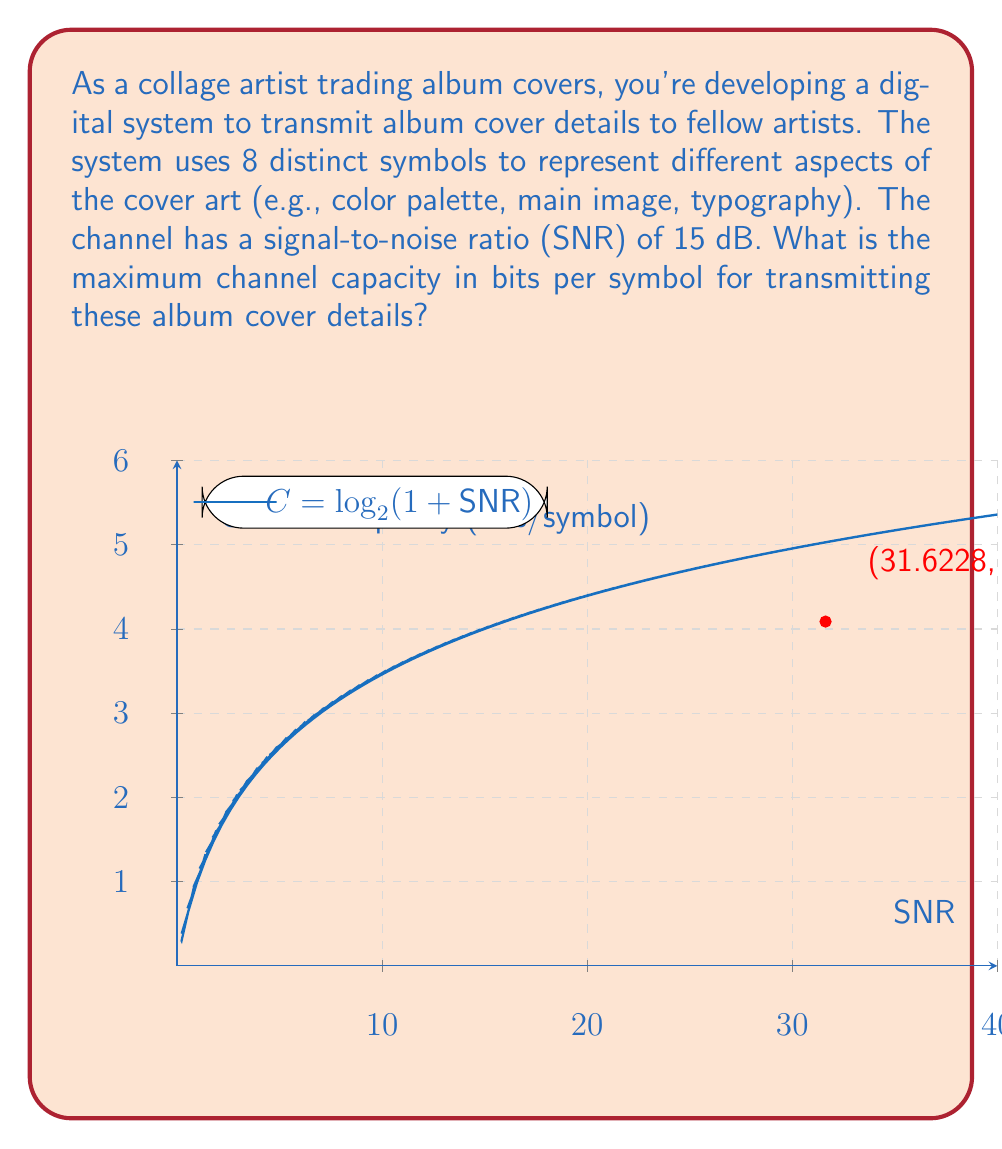Can you solve this math problem? To solve this problem, we'll use the Shannon-Hartley theorem, which relates channel capacity to bandwidth and signal-to-noise ratio. The steps are as follows:

1) The Shannon-Hartley theorem states that the channel capacity $C$ in bits per second is given by:

   $$C = B \log_2(1 + SNR)$$

   where $B$ is the bandwidth in Hz, and SNR is the signal-to-noise ratio.

2) In this case, we're interested in bits per symbol, not bits per second. Since we have 8 distinct symbols, we can treat our system as having a bandwidth of 1 symbol per transmission. So $B = 1$.

3) The SNR is given in dB, but we need it in its linear form. To convert from dB to linear form:

   $$SNR_{linear} = 10^{\frac{SNR_{dB}}{10}}$$

4) Let's calculate:

   $$SNR_{linear} = 10^{\frac{15}{10}} = 10^{1.5} \approx 31.6228$$

5) Now we can apply the Shannon-Hartley theorem:

   $$C = 1 \cdot \log_2(1 + 31.6228)$$

6) Calculating this:

   $$C = \log_2(32.6228) \approx 4.0875 \text{ bits/symbol}$$

This means that under ideal conditions, we can transmit up to 4.0875 bits of information per symbol through this channel.
Answer: 4.0875 bits/symbol 